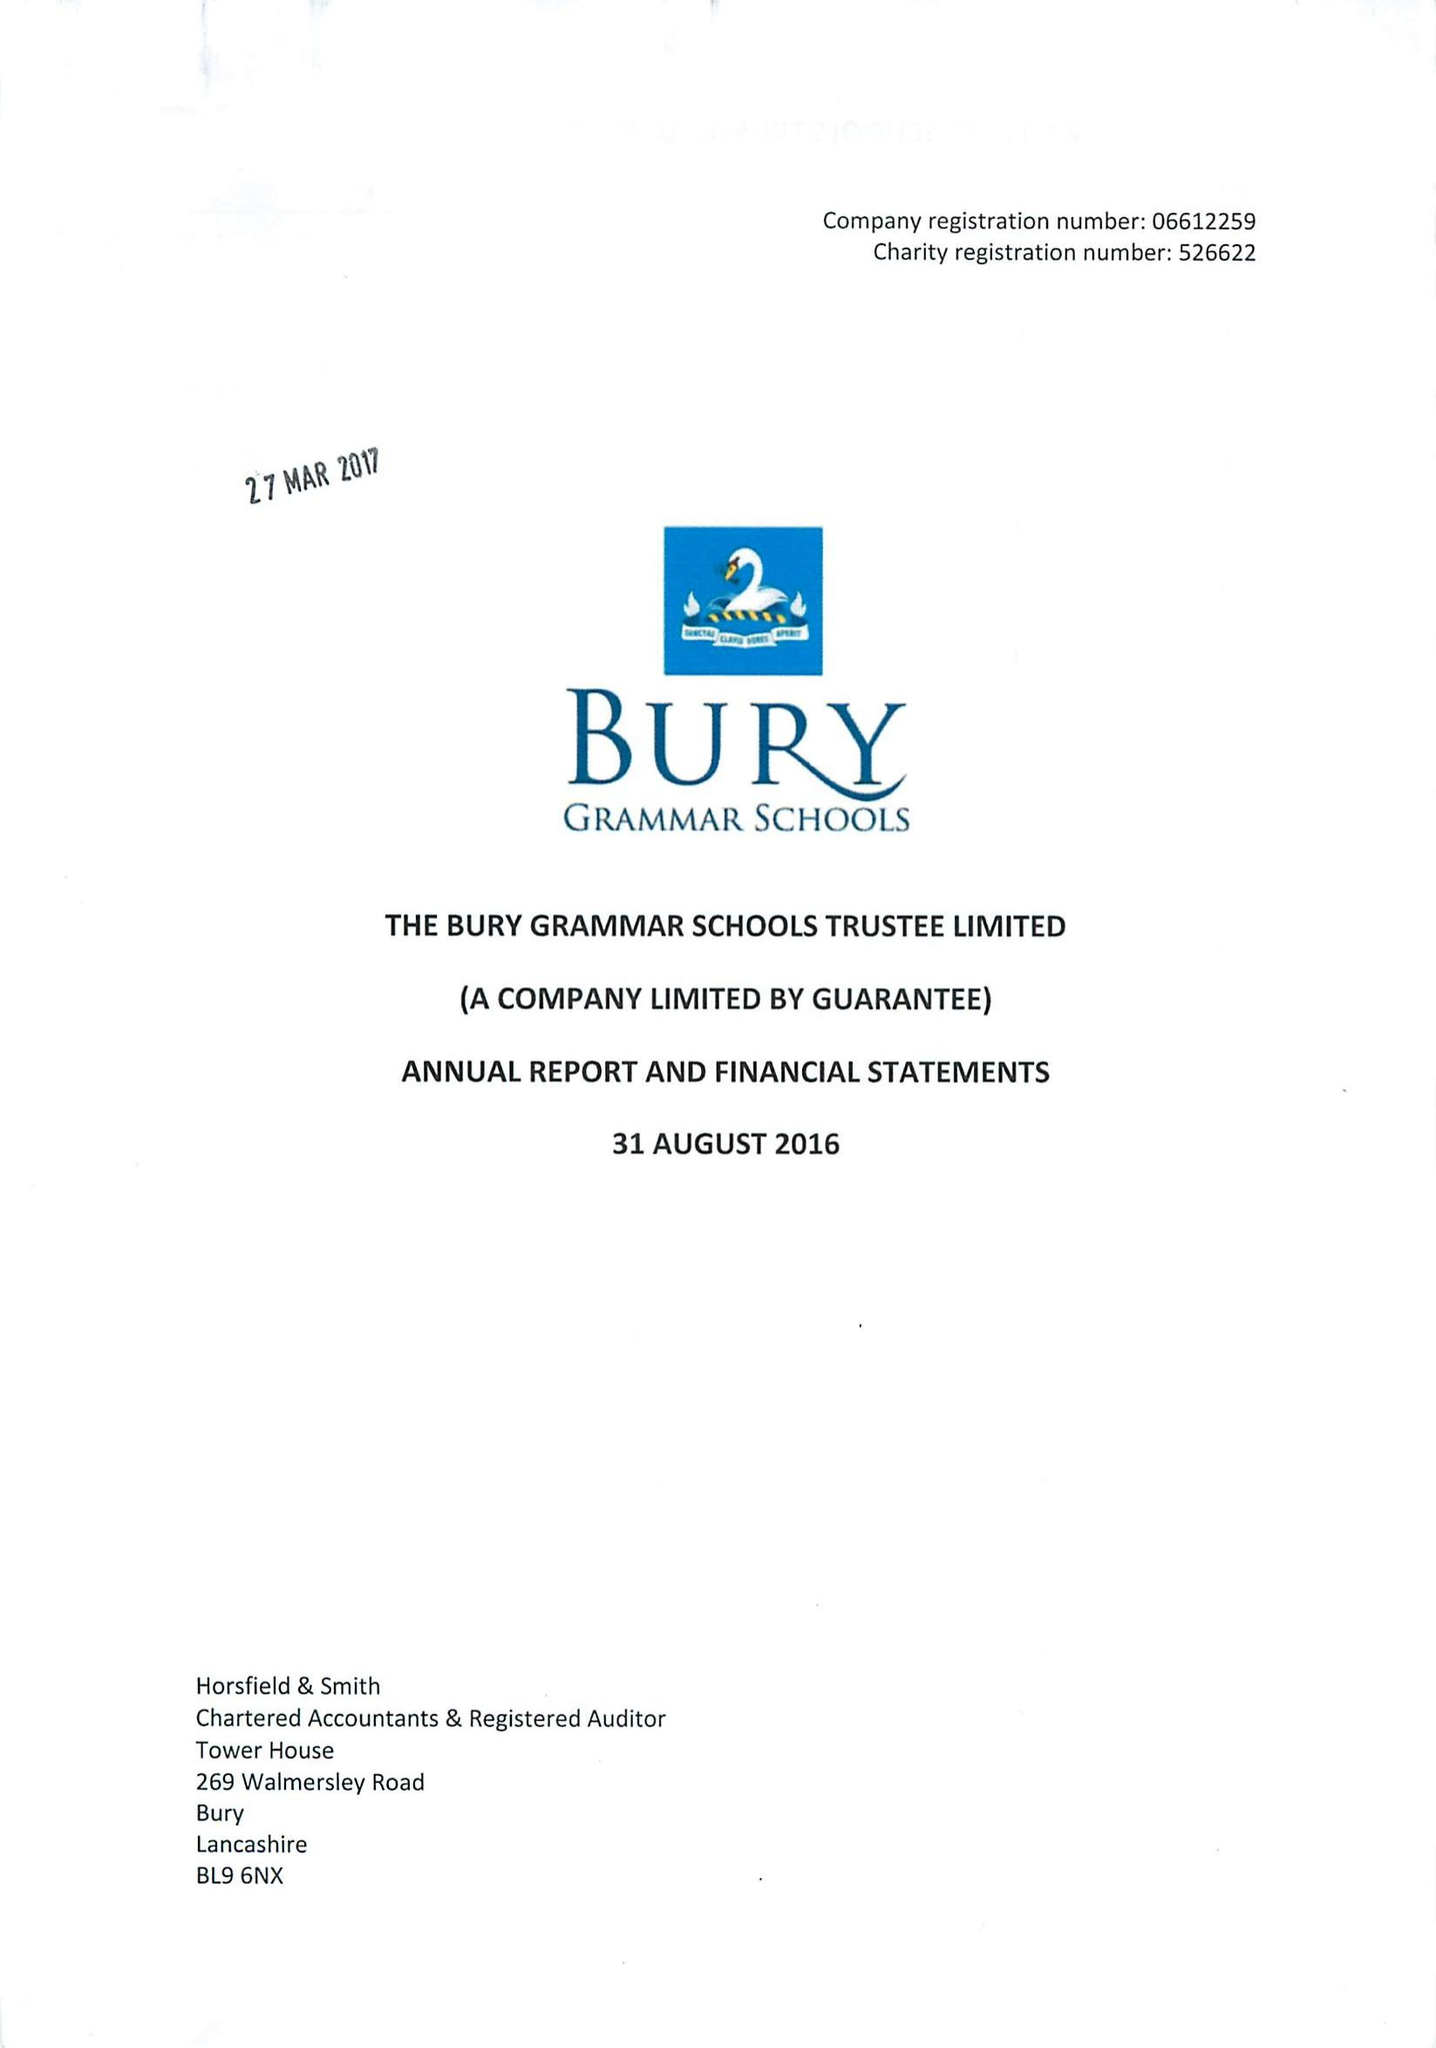What is the value for the income_annually_in_british_pounds?
Answer the question using a single word or phrase. 13194000.00 